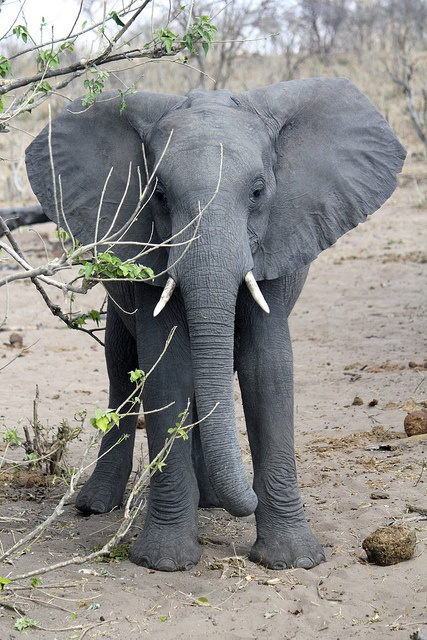Describe the objects in this image and their specific colors. I can see a elephant in darkgray, gray, and black tones in this image. 